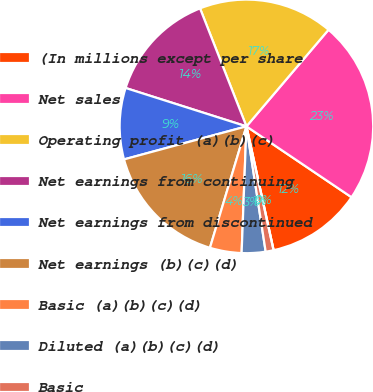Convert chart to OTSL. <chart><loc_0><loc_0><loc_500><loc_500><pie_chart><fcel>(In millions except per share<fcel>Net sales<fcel>Operating profit (a)(b)(c)<fcel>Net earnings from continuing<fcel>Net earnings from discontinued<fcel>Net earnings (b)(c)(d)<fcel>Basic (a)(b)(c)(d)<fcel>Diluted (a)(b)(c)(d)<fcel>Basic<fcel>Diluted<nl><fcel>12.12%<fcel>23.23%<fcel>17.17%<fcel>14.14%<fcel>9.09%<fcel>16.16%<fcel>4.04%<fcel>3.03%<fcel>1.01%<fcel>0.0%<nl></chart> 